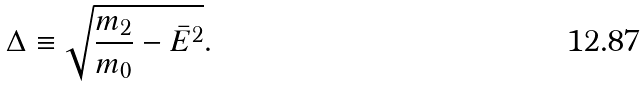<formula> <loc_0><loc_0><loc_500><loc_500>\Delta \equiv \sqrt { \frac { m _ { 2 } } { m _ { 0 } } - \bar { E } ^ { 2 } } .</formula> 